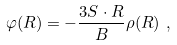<formula> <loc_0><loc_0><loc_500><loc_500>\varphi ( { R } ) = - \frac { 3 { S } \cdot { R } } { B } \rho ( R ) \ ,</formula> 